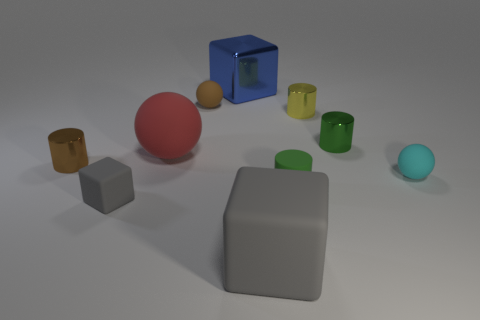Do the gray object that is in front of the small block and the large blue shiny thing have the same shape?
Ensure brevity in your answer.  Yes. There is a brown cylinder that is on the left side of the small cube to the left of the cyan matte object; how many big cubes are behind it?
Your response must be concise. 1. Is there anything else that is the same shape as the small cyan object?
Provide a succinct answer. Yes. What number of objects are either small cyan matte balls or big red rubber spheres?
Make the answer very short. 2. Do the tiny cyan rubber thing and the gray matte thing that is on the right side of the tiny cube have the same shape?
Your response must be concise. No. What shape is the gray matte object on the right side of the blue metallic object?
Provide a short and direct response. Cube. Is the shape of the tiny yellow object the same as the big gray object?
Ensure brevity in your answer.  No. There is another matte thing that is the same shape as the tiny yellow object; what size is it?
Offer a terse response. Small. There is a gray block to the right of the red rubber sphere; is its size the same as the small cyan matte object?
Your answer should be very brief. No. What is the size of the ball that is both left of the yellow metal thing and on the right side of the big rubber sphere?
Your response must be concise. Small. 